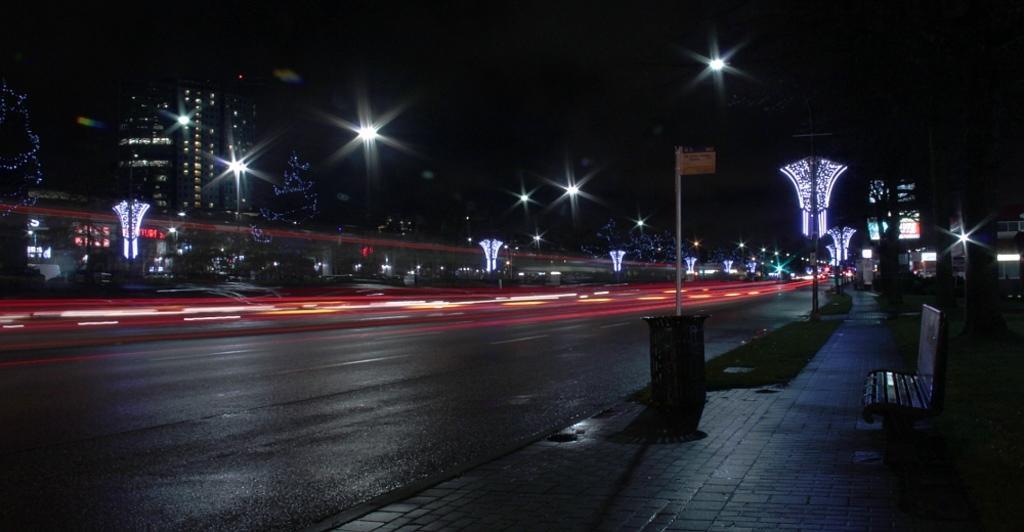In one or two sentences, can you explain what this image depicts? In the image we can see the road and poles. We can even see there are lights and buildings. Here we can see the bench, grass and the board. 